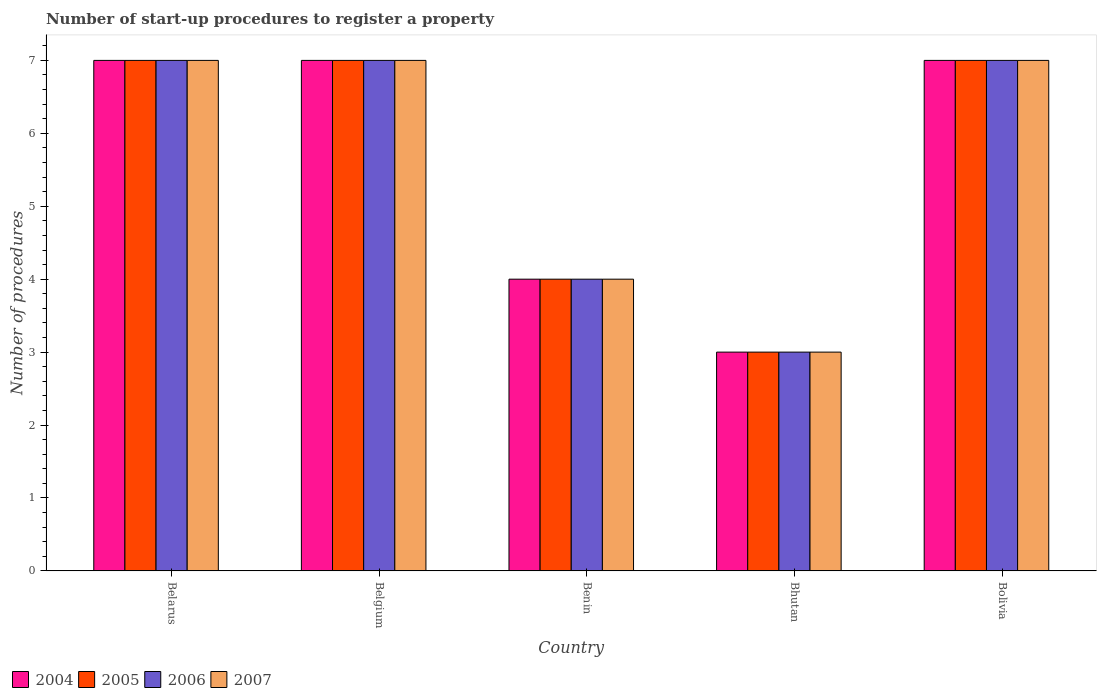How many groups of bars are there?
Ensure brevity in your answer.  5. Are the number of bars on each tick of the X-axis equal?
Give a very brief answer. Yes. What is the label of the 3rd group of bars from the left?
Offer a very short reply. Benin. In how many cases, is the number of bars for a given country not equal to the number of legend labels?
Your answer should be very brief. 0. Across all countries, what is the maximum number of procedures required to register a property in 2004?
Make the answer very short. 7. In which country was the number of procedures required to register a property in 2005 maximum?
Ensure brevity in your answer.  Belarus. In which country was the number of procedures required to register a property in 2004 minimum?
Ensure brevity in your answer.  Bhutan. What is the difference between the number of procedures required to register a property in 2007 in Belgium and that in Bolivia?
Offer a very short reply. 0. What is the difference between the number of procedures required to register a property in 2005 in Belgium and the number of procedures required to register a property in 2004 in Bolivia?
Provide a succinct answer. 0. What is the ratio of the number of procedures required to register a property in 2007 in Bhutan to that in Bolivia?
Your answer should be compact. 0.43. Is the sum of the number of procedures required to register a property in 2004 in Belgium and Bolivia greater than the maximum number of procedures required to register a property in 2006 across all countries?
Offer a very short reply. Yes. Is it the case that in every country, the sum of the number of procedures required to register a property in 2006 and number of procedures required to register a property in 2004 is greater than the sum of number of procedures required to register a property in 2007 and number of procedures required to register a property in 2005?
Provide a short and direct response. No. What does the 3rd bar from the left in Bolivia represents?
Your response must be concise. 2006. How many bars are there?
Provide a short and direct response. 20. Are all the bars in the graph horizontal?
Your response must be concise. No. Are the values on the major ticks of Y-axis written in scientific E-notation?
Offer a very short reply. No. Does the graph contain any zero values?
Offer a terse response. No. Does the graph contain grids?
Your response must be concise. No. Where does the legend appear in the graph?
Provide a succinct answer. Bottom left. How many legend labels are there?
Offer a very short reply. 4. What is the title of the graph?
Make the answer very short. Number of start-up procedures to register a property. Does "2009" appear as one of the legend labels in the graph?
Keep it short and to the point. No. What is the label or title of the Y-axis?
Your response must be concise. Number of procedures. What is the Number of procedures in 2005 in Belarus?
Make the answer very short. 7. What is the Number of procedures in 2006 in Belarus?
Ensure brevity in your answer.  7. What is the Number of procedures of 2007 in Belarus?
Your answer should be compact. 7. What is the Number of procedures in 2004 in Belgium?
Provide a short and direct response. 7. What is the Number of procedures of 2004 in Benin?
Provide a short and direct response. 4. What is the Number of procedures of 2005 in Benin?
Your answer should be compact. 4. What is the Number of procedures in 2006 in Benin?
Keep it short and to the point. 4. What is the Number of procedures in 2007 in Benin?
Offer a very short reply. 4. What is the Number of procedures in 2005 in Bhutan?
Your response must be concise. 3. What is the Number of procedures of 2006 in Bhutan?
Offer a terse response. 3. What is the Number of procedures of 2007 in Bhutan?
Your answer should be very brief. 3. What is the Number of procedures in 2006 in Bolivia?
Your response must be concise. 7. Across all countries, what is the maximum Number of procedures in 2004?
Offer a terse response. 7. Across all countries, what is the maximum Number of procedures of 2006?
Provide a short and direct response. 7. Across all countries, what is the maximum Number of procedures in 2007?
Keep it short and to the point. 7. What is the total Number of procedures in 2006 in the graph?
Provide a short and direct response. 28. What is the total Number of procedures of 2007 in the graph?
Provide a short and direct response. 28. What is the difference between the Number of procedures of 2004 in Belarus and that in Belgium?
Make the answer very short. 0. What is the difference between the Number of procedures of 2004 in Belarus and that in Benin?
Give a very brief answer. 3. What is the difference between the Number of procedures in 2005 in Belarus and that in Benin?
Your answer should be very brief. 3. What is the difference between the Number of procedures of 2007 in Belarus and that in Benin?
Offer a terse response. 3. What is the difference between the Number of procedures in 2005 in Belarus and that in Bhutan?
Provide a succinct answer. 4. What is the difference between the Number of procedures of 2007 in Belarus and that in Bhutan?
Provide a succinct answer. 4. What is the difference between the Number of procedures in 2004 in Belarus and that in Bolivia?
Give a very brief answer. 0. What is the difference between the Number of procedures in 2005 in Belarus and that in Bolivia?
Offer a terse response. 0. What is the difference between the Number of procedures in 2007 in Belarus and that in Bolivia?
Provide a succinct answer. 0. What is the difference between the Number of procedures in 2005 in Belgium and that in Benin?
Make the answer very short. 3. What is the difference between the Number of procedures in 2006 in Belgium and that in Benin?
Offer a terse response. 3. What is the difference between the Number of procedures in 2004 in Belgium and that in Bhutan?
Your response must be concise. 4. What is the difference between the Number of procedures in 2006 in Belgium and that in Bhutan?
Your response must be concise. 4. What is the difference between the Number of procedures in 2004 in Belgium and that in Bolivia?
Your answer should be very brief. 0. What is the difference between the Number of procedures in 2004 in Benin and that in Bhutan?
Ensure brevity in your answer.  1. What is the difference between the Number of procedures in 2004 in Benin and that in Bolivia?
Provide a short and direct response. -3. What is the difference between the Number of procedures of 2005 in Benin and that in Bolivia?
Your answer should be compact. -3. What is the difference between the Number of procedures in 2006 in Benin and that in Bolivia?
Offer a very short reply. -3. What is the difference between the Number of procedures of 2007 in Benin and that in Bolivia?
Give a very brief answer. -3. What is the difference between the Number of procedures of 2005 in Bhutan and that in Bolivia?
Keep it short and to the point. -4. What is the difference between the Number of procedures in 2007 in Bhutan and that in Bolivia?
Offer a very short reply. -4. What is the difference between the Number of procedures in 2004 in Belarus and the Number of procedures in 2006 in Belgium?
Offer a terse response. 0. What is the difference between the Number of procedures in 2004 in Belarus and the Number of procedures in 2007 in Belgium?
Your answer should be very brief. 0. What is the difference between the Number of procedures of 2005 in Belarus and the Number of procedures of 2006 in Belgium?
Provide a succinct answer. 0. What is the difference between the Number of procedures of 2005 in Belarus and the Number of procedures of 2007 in Belgium?
Your response must be concise. 0. What is the difference between the Number of procedures in 2004 in Belarus and the Number of procedures in 2006 in Benin?
Your answer should be compact. 3. What is the difference between the Number of procedures in 2005 in Belarus and the Number of procedures in 2007 in Benin?
Give a very brief answer. 3. What is the difference between the Number of procedures in 2004 in Belarus and the Number of procedures in 2005 in Bhutan?
Offer a terse response. 4. What is the difference between the Number of procedures of 2004 in Belarus and the Number of procedures of 2006 in Bhutan?
Ensure brevity in your answer.  4. What is the difference between the Number of procedures of 2005 in Belarus and the Number of procedures of 2007 in Bhutan?
Offer a terse response. 4. What is the difference between the Number of procedures of 2004 in Belarus and the Number of procedures of 2005 in Bolivia?
Ensure brevity in your answer.  0. What is the difference between the Number of procedures of 2004 in Belarus and the Number of procedures of 2006 in Bolivia?
Ensure brevity in your answer.  0. What is the difference between the Number of procedures of 2005 in Belarus and the Number of procedures of 2006 in Bolivia?
Make the answer very short. 0. What is the difference between the Number of procedures of 2005 in Belarus and the Number of procedures of 2007 in Bolivia?
Keep it short and to the point. 0. What is the difference between the Number of procedures in 2006 in Belarus and the Number of procedures in 2007 in Bolivia?
Offer a terse response. 0. What is the difference between the Number of procedures in 2004 in Belgium and the Number of procedures in 2005 in Benin?
Provide a succinct answer. 3. What is the difference between the Number of procedures of 2004 in Belgium and the Number of procedures of 2005 in Bhutan?
Your response must be concise. 4. What is the difference between the Number of procedures in 2004 in Belgium and the Number of procedures in 2006 in Bhutan?
Your answer should be very brief. 4. What is the difference between the Number of procedures of 2004 in Belgium and the Number of procedures of 2007 in Bhutan?
Offer a terse response. 4. What is the difference between the Number of procedures of 2005 in Belgium and the Number of procedures of 2006 in Bhutan?
Provide a succinct answer. 4. What is the difference between the Number of procedures of 2006 in Belgium and the Number of procedures of 2007 in Bhutan?
Provide a succinct answer. 4. What is the difference between the Number of procedures in 2004 in Belgium and the Number of procedures in 2005 in Bolivia?
Make the answer very short. 0. What is the difference between the Number of procedures in 2004 in Belgium and the Number of procedures in 2006 in Bolivia?
Make the answer very short. 0. What is the difference between the Number of procedures in 2004 in Belgium and the Number of procedures in 2007 in Bolivia?
Provide a short and direct response. 0. What is the difference between the Number of procedures of 2005 in Belgium and the Number of procedures of 2007 in Bolivia?
Offer a very short reply. 0. What is the difference between the Number of procedures in 2006 in Belgium and the Number of procedures in 2007 in Bolivia?
Keep it short and to the point. 0. What is the difference between the Number of procedures of 2005 in Benin and the Number of procedures of 2006 in Bhutan?
Offer a terse response. 1. What is the difference between the Number of procedures of 2006 in Benin and the Number of procedures of 2007 in Bhutan?
Ensure brevity in your answer.  1. What is the difference between the Number of procedures of 2004 in Benin and the Number of procedures of 2006 in Bolivia?
Ensure brevity in your answer.  -3. What is the difference between the Number of procedures of 2004 in Benin and the Number of procedures of 2007 in Bolivia?
Provide a short and direct response. -3. What is the difference between the Number of procedures in 2005 in Benin and the Number of procedures in 2006 in Bolivia?
Offer a very short reply. -3. What is the difference between the Number of procedures in 2004 in Bhutan and the Number of procedures in 2007 in Bolivia?
Ensure brevity in your answer.  -4. What is the difference between the Number of procedures in 2006 in Bhutan and the Number of procedures in 2007 in Bolivia?
Provide a short and direct response. -4. What is the average Number of procedures of 2004 per country?
Give a very brief answer. 5.6. What is the average Number of procedures in 2006 per country?
Give a very brief answer. 5.6. What is the average Number of procedures in 2007 per country?
Your response must be concise. 5.6. What is the difference between the Number of procedures in 2004 and Number of procedures in 2007 in Belarus?
Your answer should be very brief. 0. What is the difference between the Number of procedures of 2004 and Number of procedures of 2006 in Belgium?
Your answer should be very brief. 0. What is the difference between the Number of procedures of 2004 and Number of procedures of 2007 in Belgium?
Ensure brevity in your answer.  0. What is the difference between the Number of procedures in 2005 and Number of procedures in 2006 in Belgium?
Your answer should be compact. 0. What is the difference between the Number of procedures in 2004 and Number of procedures in 2005 in Benin?
Give a very brief answer. 0. What is the difference between the Number of procedures in 2004 and Number of procedures in 2006 in Benin?
Provide a short and direct response. 0. What is the difference between the Number of procedures in 2005 and Number of procedures in 2006 in Benin?
Your answer should be compact. 0. What is the difference between the Number of procedures in 2004 and Number of procedures in 2005 in Bhutan?
Your answer should be compact. 0. What is the difference between the Number of procedures of 2005 and Number of procedures of 2006 in Bhutan?
Your response must be concise. 0. What is the difference between the Number of procedures of 2006 and Number of procedures of 2007 in Bhutan?
Ensure brevity in your answer.  0. What is the difference between the Number of procedures in 2004 and Number of procedures in 2005 in Bolivia?
Keep it short and to the point. 0. What is the difference between the Number of procedures of 2004 and Number of procedures of 2006 in Bolivia?
Your answer should be very brief. 0. What is the difference between the Number of procedures in 2004 and Number of procedures in 2007 in Bolivia?
Ensure brevity in your answer.  0. What is the ratio of the Number of procedures in 2004 in Belarus to that in Belgium?
Provide a short and direct response. 1. What is the ratio of the Number of procedures in 2005 in Belarus to that in Belgium?
Provide a succinct answer. 1. What is the ratio of the Number of procedures in 2007 in Belarus to that in Belgium?
Your answer should be very brief. 1. What is the ratio of the Number of procedures of 2006 in Belarus to that in Benin?
Keep it short and to the point. 1.75. What is the ratio of the Number of procedures of 2007 in Belarus to that in Benin?
Provide a succinct answer. 1.75. What is the ratio of the Number of procedures in 2004 in Belarus to that in Bhutan?
Your answer should be compact. 2.33. What is the ratio of the Number of procedures of 2005 in Belarus to that in Bhutan?
Your response must be concise. 2.33. What is the ratio of the Number of procedures in 2006 in Belarus to that in Bhutan?
Give a very brief answer. 2.33. What is the ratio of the Number of procedures in 2007 in Belarus to that in Bhutan?
Your response must be concise. 2.33. What is the ratio of the Number of procedures in 2004 in Belarus to that in Bolivia?
Give a very brief answer. 1. What is the ratio of the Number of procedures in 2005 in Belarus to that in Bolivia?
Ensure brevity in your answer.  1. What is the ratio of the Number of procedures of 2004 in Belgium to that in Bhutan?
Provide a succinct answer. 2.33. What is the ratio of the Number of procedures of 2005 in Belgium to that in Bhutan?
Provide a succinct answer. 2.33. What is the ratio of the Number of procedures in 2006 in Belgium to that in Bhutan?
Give a very brief answer. 2.33. What is the ratio of the Number of procedures in 2007 in Belgium to that in Bhutan?
Give a very brief answer. 2.33. What is the ratio of the Number of procedures of 2005 in Belgium to that in Bolivia?
Give a very brief answer. 1. What is the ratio of the Number of procedures of 2007 in Belgium to that in Bolivia?
Your answer should be very brief. 1. What is the ratio of the Number of procedures of 2004 in Benin to that in Bhutan?
Your answer should be very brief. 1.33. What is the ratio of the Number of procedures in 2006 in Benin to that in Bhutan?
Offer a very short reply. 1.33. What is the ratio of the Number of procedures of 2007 in Benin to that in Bhutan?
Provide a short and direct response. 1.33. What is the ratio of the Number of procedures of 2004 in Benin to that in Bolivia?
Ensure brevity in your answer.  0.57. What is the ratio of the Number of procedures of 2007 in Benin to that in Bolivia?
Offer a terse response. 0.57. What is the ratio of the Number of procedures in 2004 in Bhutan to that in Bolivia?
Give a very brief answer. 0.43. What is the ratio of the Number of procedures in 2005 in Bhutan to that in Bolivia?
Ensure brevity in your answer.  0.43. What is the ratio of the Number of procedures of 2006 in Bhutan to that in Bolivia?
Make the answer very short. 0.43. What is the ratio of the Number of procedures of 2007 in Bhutan to that in Bolivia?
Provide a succinct answer. 0.43. What is the difference between the highest and the second highest Number of procedures of 2005?
Offer a terse response. 0. What is the difference between the highest and the second highest Number of procedures in 2006?
Offer a terse response. 0. What is the difference between the highest and the second highest Number of procedures in 2007?
Your answer should be compact. 0. What is the difference between the highest and the lowest Number of procedures of 2005?
Make the answer very short. 4. What is the difference between the highest and the lowest Number of procedures of 2006?
Your answer should be very brief. 4. 